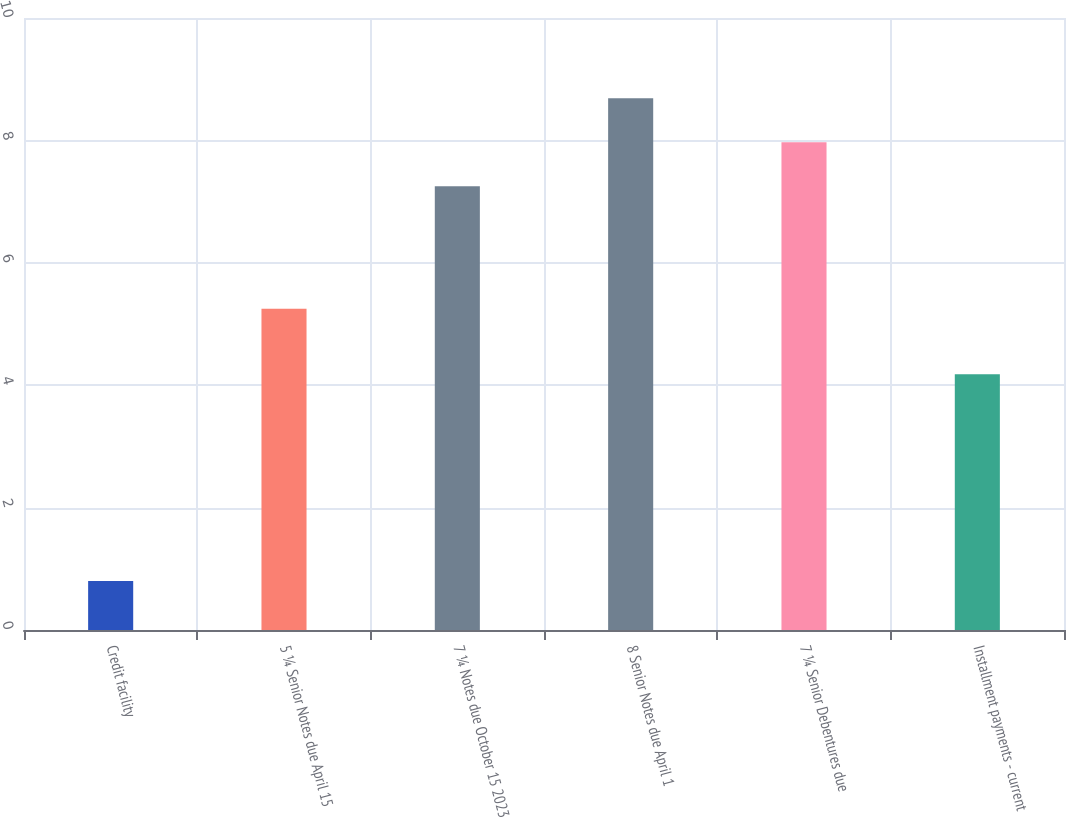Convert chart. <chart><loc_0><loc_0><loc_500><loc_500><bar_chart><fcel>Credit facility<fcel>5 ¼ Senior Notes due April 15<fcel>7 ¼ Notes due October 15 2023<fcel>8 Senior Notes due April 1<fcel>7 ¼ Senior Debentures due<fcel>Installment payments - current<nl><fcel>0.8<fcel>5.25<fcel>7.25<fcel>8.69<fcel>7.97<fcel>4.18<nl></chart> 